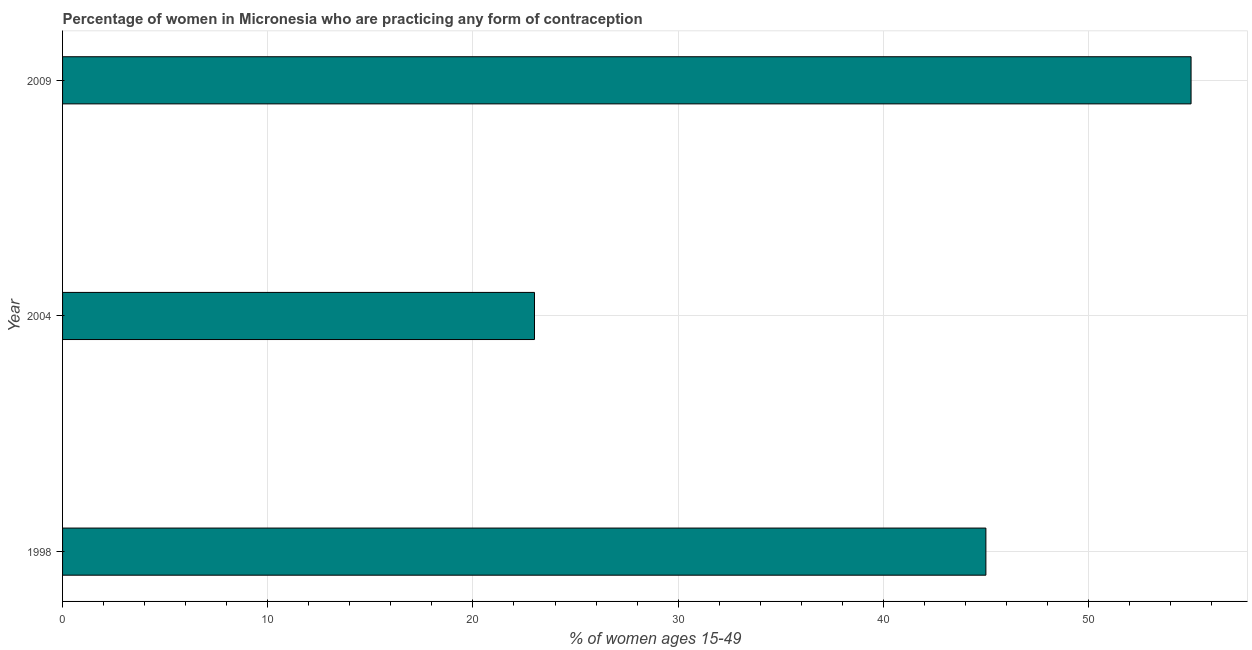Does the graph contain grids?
Your response must be concise. Yes. What is the title of the graph?
Keep it short and to the point. Percentage of women in Micronesia who are practicing any form of contraception. What is the label or title of the X-axis?
Make the answer very short. % of women ages 15-49. What is the contraceptive prevalence in 1998?
Your response must be concise. 45. Across all years, what is the maximum contraceptive prevalence?
Your answer should be compact. 55. Across all years, what is the minimum contraceptive prevalence?
Your answer should be compact. 23. In which year was the contraceptive prevalence minimum?
Your response must be concise. 2004. What is the sum of the contraceptive prevalence?
Your response must be concise. 123. What is the median contraceptive prevalence?
Offer a very short reply. 45. What is the ratio of the contraceptive prevalence in 1998 to that in 2004?
Offer a terse response. 1.96. Is the contraceptive prevalence in 1998 less than that in 2004?
Your answer should be compact. No. What is the difference between the highest and the second highest contraceptive prevalence?
Your answer should be very brief. 10. Is the sum of the contraceptive prevalence in 1998 and 2009 greater than the maximum contraceptive prevalence across all years?
Keep it short and to the point. Yes. What is the difference between the highest and the lowest contraceptive prevalence?
Provide a short and direct response. 32. Are all the bars in the graph horizontal?
Offer a terse response. Yes. What is the difference between two consecutive major ticks on the X-axis?
Give a very brief answer. 10. What is the % of women ages 15-49 of 1998?
Offer a terse response. 45. What is the difference between the % of women ages 15-49 in 1998 and 2004?
Provide a short and direct response. 22. What is the difference between the % of women ages 15-49 in 1998 and 2009?
Give a very brief answer. -10. What is the difference between the % of women ages 15-49 in 2004 and 2009?
Offer a terse response. -32. What is the ratio of the % of women ages 15-49 in 1998 to that in 2004?
Provide a succinct answer. 1.96. What is the ratio of the % of women ages 15-49 in 1998 to that in 2009?
Offer a very short reply. 0.82. What is the ratio of the % of women ages 15-49 in 2004 to that in 2009?
Provide a short and direct response. 0.42. 